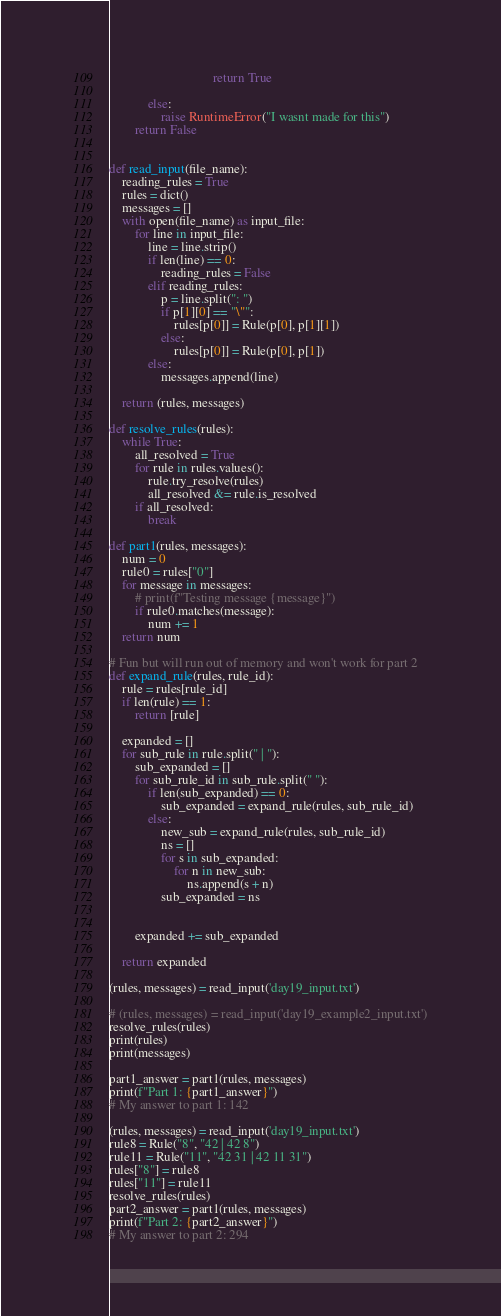Convert code to text. <code><loc_0><loc_0><loc_500><loc_500><_Python_>                                return True

            else:
                raise RuntimeError("I wasnt made for this")
        return False


def read_input(file_name):
    reading_rules = True
    rules = dict()
    messages = []
    with open(file_name) as input_file:
        for line in input_file:
            line = line.strip()
            if len(line) == 0:
                reading_rules = False
            elif reading_rules:
                p = line.split(": ")
                if p[1][0] == "\"":
                    rules[p[0]] = Rule(p[0], p[1][1])
                else:
                    rules[p[0]] = Rule(p[0], p[1])
            else:
                messages.append(line)

    return (rules, messages)

def resolve_rules(rules):
    while True:
        all_resolved = True
        for rule in rules.values():
            rule.try_resolve(rules)
            all_resolved &= rule.is_resolved
        if all_resolved:
            break

def part1(rules, messages):
    num = 0
    rule0 = rules["0"]
    for message in messages:
        # print(f"Testing message {message}")
        if rule0.matches(message):
            num += 1
    return num

# Fun but will run out of memory and won't work for part 2
def expand_rule(rules, rule_id):
    rule = rules[rule_id]
    if len(rule) == 1:
        return [rule]

    expanded = []
    for sub_rule in rule.split(" | "):
        sub_expanded = []
        for sub_rule_id in sub_rule.split(" "):
            if len(sub_expanded) == 0:
                sub_expanded = expand_rule(rules, sub_rule_id)
            else:
                new_sub = expand_rule(rules, sub_rule_id)
                ns = []
                for s in sub_expanded:
                    for n in new_sub:
                        ns.append(s + n)
                sub_expanded = ns

            
        expanded += sub_expanded

    return expanded

(rules, messages) = read_input('day19_input.txt')

# (rules, messages) = read_input('day19_example2_input.txt')
resolve_rules(rules)
print(rules)
print(messages)

part1_answer = part1(rules, messages)
print(f"Part 1: {part1_answer}")
# My answer to part 1: 142

(rules, messages) = read_input('day19_input.txt')
rule8 = Rule("8", "42 | 42 8")
rule11 = Rule("11", "42 31 | 42 11 31")
rules["8"] = rule8
rules["11"] = rule11
resolve_rules(rules)
part2_answer = part1(rules, messages)
print(f"Part 2: {part2_answer}")
# My answer to part 2: 294
</code> 